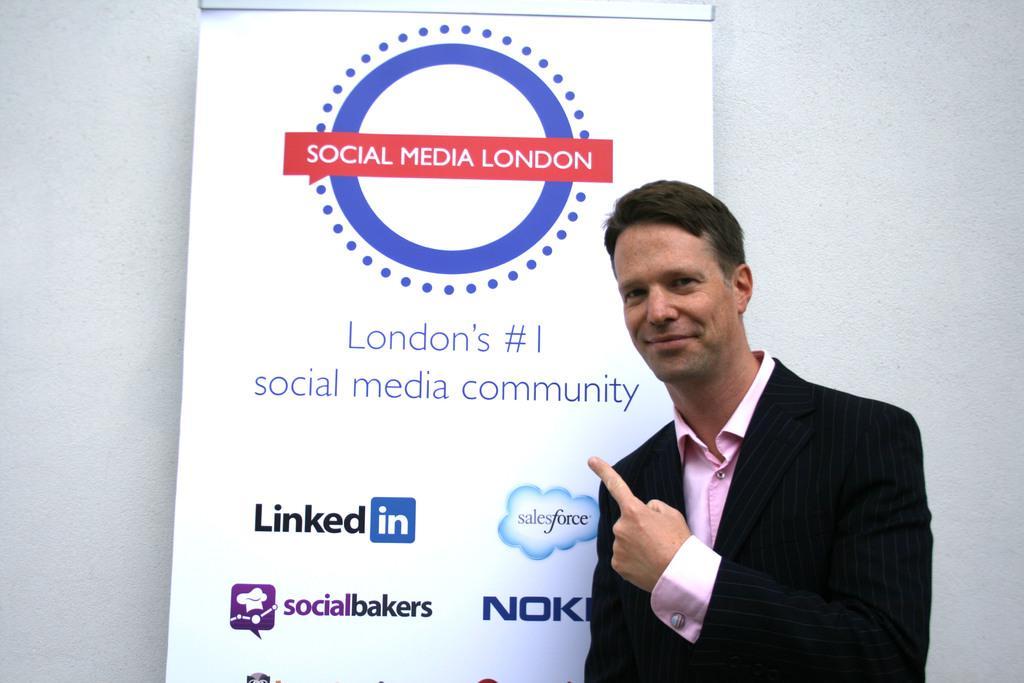Please provide a concise description of this image. In this image there is a man standing, in the background there is a poster, on that poster there is some text, behind the poster there is some text. 